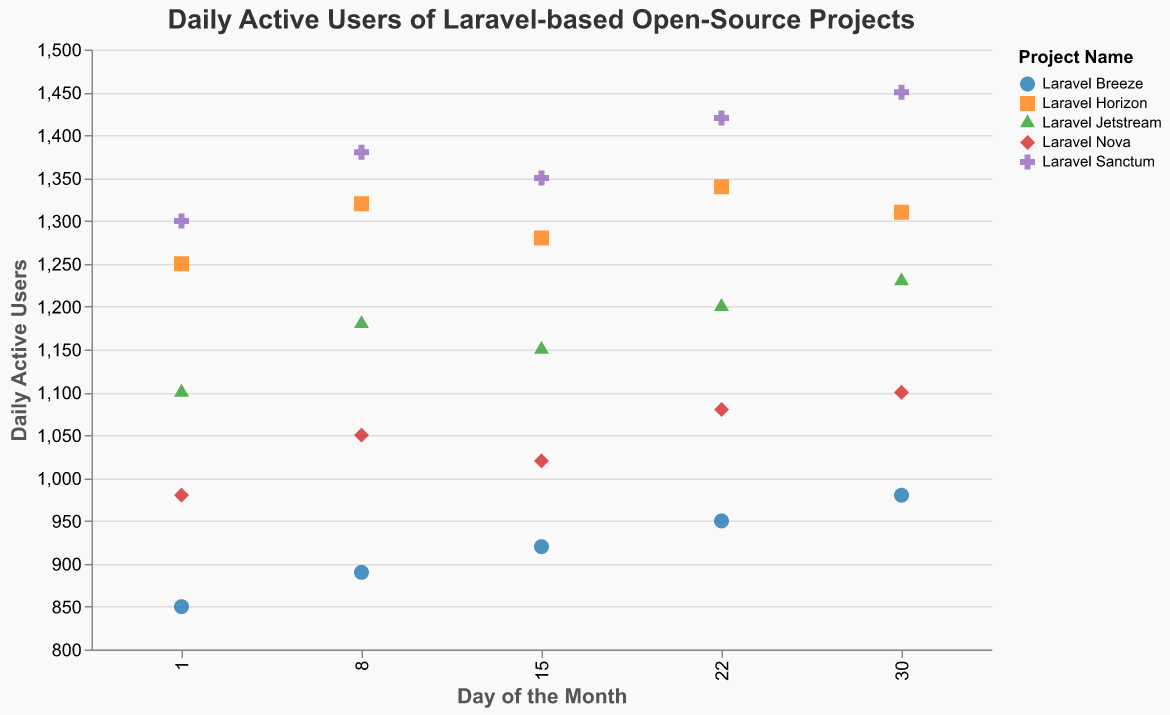What is the title of the strip plot? The title is located at the top of the strip plot and reads "Daily Active Users of Laravel-based Open-Source Projects."
Answer: Daily Active Users of Laravel-based Open-Source Projects Which project had the highest daily active users on the 30th day? Look at the day 30 on the x-axis and compare the y-axis values for each project. "Laravel Sanctum" has the highest y-axis value on the 30th day.
Answer: Laravel Sanctum How do daily active users of Laravel Breeze change from day 1 to day 30? Track the y-axis values along the x-axis points for "Laravel Breeze" on days 1 (850), 8 (890), 15 (920), 22 (950), and 30 (980) to see the increase.
Answer: They increase Which two projects show the most similar trends in daily active users over the month? Examine the trajectories of the points for "Laravel Horizon" and "Laravel Sanctum". Both projects show consistently high daily active user counts, increasing over time.
Answer: Laravel Horizon and Laravel Sanctum What is the range of daily active users for Laravel Nova throughout the month? Identify the minimum and maximum y-axis values for "Laravel Nova": minimum is 980 on day 1 and maximum is 1100 on day 30.
Answer: 980 to 1100 Which project showed the least increase in daily active users over the month? Compare the day 1 and day 30 values for each project. "Laravel Breeze" increased from 850 on day 1 to 980 on day 30, which is the smallest increase.
Answer: Laravel Breeze How many unique projects are represented in the strip plot? Count the distinct projects listed in the legend or visible in the plot. There are five distinct projects.
Answer: 5 On which day did Laravel Jetstream have the highest number of daily active users? Compare y-axis values for "Laravel Jetstream" across days 1 (1100), 8 (1180), 15 (1150), 22 (1200), and 30 (1230). The highest value is on day 30.
Answer: Day 30 What is the average daily active users for Laravel Sanctum over the month? Sum the y-axis values for "Laravel Sanctum" on days 1 (1300), 8 (1380), 15 (1350), 22 (1420), and 30 (1450), then divide by 5. (1300 + 1380 + 1350 + 1420 + 1450) / 5 = 1380
Answer: 1380 